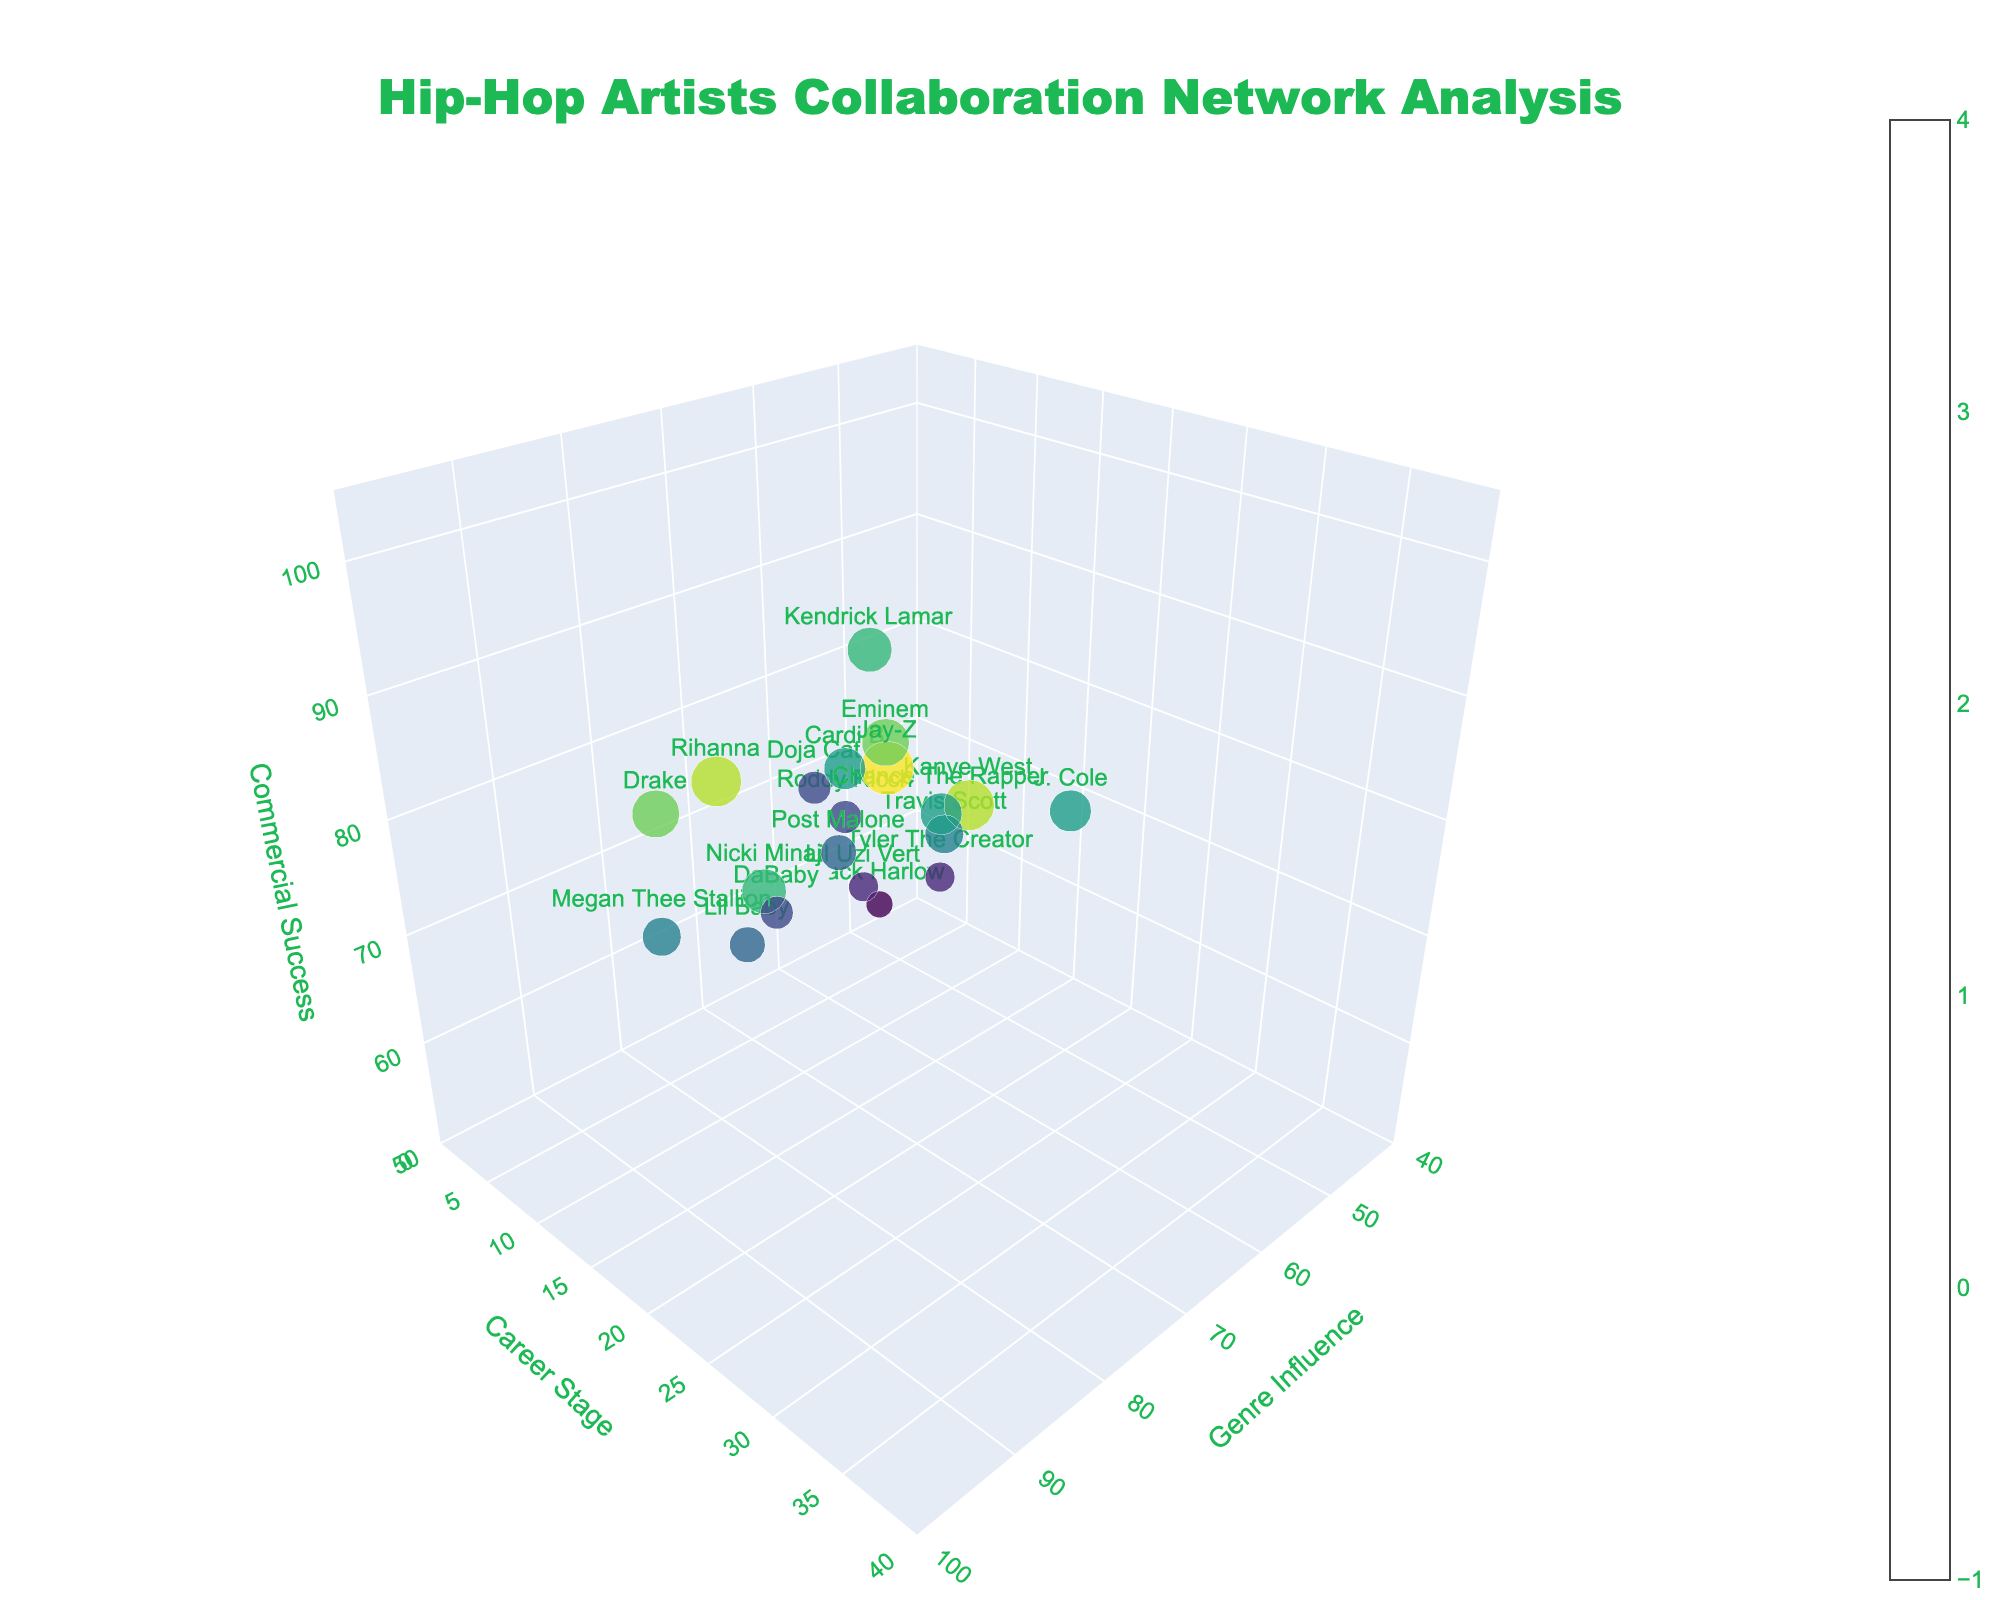What is the title of the figure? The title is usually the largest text on the figure and is located at the top. In this case, it reads "Hip-Hop Artists Collaboration Network Analysis".
Answer: Hip-Hop Artists Collaboration Network Analysis Which artist has the highest genre influence and what is their collaboration strength? By looking at the topmost data point on the x-axis labeled 'Genre Influence', we see that Jay-Z has the highest genre influence at 95. His collaboration strength is 90.
Answer: Jay-Z, 90 What is the range of the 'Career Stage' axis? The range of the 'Career Stage' axis can be observed by looking at its numerical labels. It ranges from 0 to 40.
Answer: 0 to 40 Among the artists with a 'Career Stage' between 10 and 20, who has the highest collaboration strength? By identifying artists in the range of 10 to 20 on the y-axis, and comparing their collaboration strengths, we find that Drake, with a career stage of 15 and collaboration strength of 80, is the highest.
Answer: Drake Which artist has the lowest commercial success and where is this data point in the plot? The lowest commercial success point is at 55 on the z-axis. By identifying the artist at this point, we see that Jack Harlow has a commercial success of 55.
Answer: Jack Harlow Compare Kendrick Lamar's genre influence and commercial success with Drake's, who has a higher combination of these two metrics? Kendrick Lamar has a genre influence of 75 and commercial success of 95, which totals 170. Drake has a genre influence of 90 and commercial success of 85, which totals 175. Therefore, Drake has a higher combination.
Answer: Drake What is the average collaboration strength of artists with a commercial success above 80? The artists with a commercial success above 80 are Drake, Kendrick Lamar, Jay-Z, Cardi B, Travis Scott, Eminem, Nicki Minaj, and Rihanna. Their collaboration strengths are 80, 75, 90, 70, 65, 80, 75, and 85 respectively. The average is calculated as (80 + 75 + 90 + 70 + 65 + 80 + 75 + 85) / 8 = 77.5.
Answer: 77.5 How many artists have a genre influence greater than 70 but less than 80? By counting the data points between 70 and 80 on the x-axis, we see that there are six artists: Kendrick Lamar, Cardi B, Travis Scott, Nicki Minaj, Chance The Rapper, and Lil Baby.
Answer: 6 Which artist has the largest marker size in the scatter plot and what does it signify? The largest marker size corresponds to Jay-Z, whose marker size is proportional to his collaboration strength of 90, the highest in the data set.
Answer: Jay-Z, highest collaboration strength Is there a noticeable relationship between career stage and commercial success for artists with collaboration strengths above 70? Examining the scatter plot, we see that most artists with collaboration strengths above 70 (Drake, Kendrick Lamar, Jay-Z, Cardi B, Eminem, Nicki Minaj) generally have high commercial success regardless of their career stage, indicating no clear linear relationship.
Answer: No clear relationship 